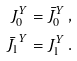<formula> <loc_0><loc_0><loc_500><loc_500>J _ { 0 } ^ { Y } & = \bar { J } _ { 0 } ^ { Y } \, , \\ \bar { J _ { 1 } } ^ { Y } & = J _ { 1 } ^ { Y } \, .</formula> 